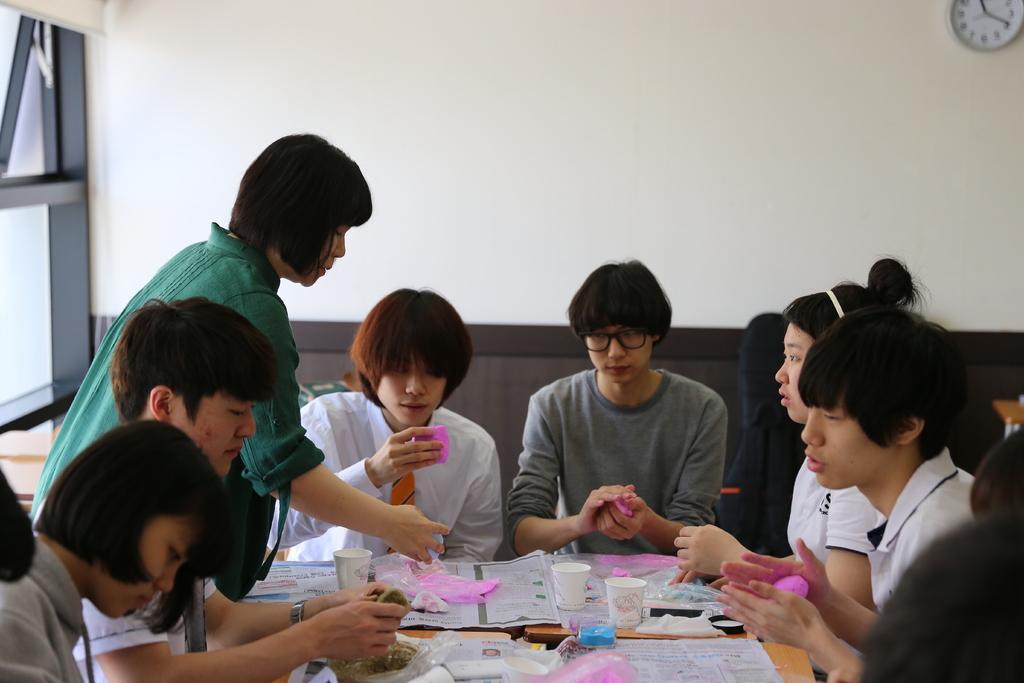Describe this image in one or two sentences. Here we can see few persons are sitting on the chairs around a table. On the table we can see papers, cups, and bottles. In the background we can see wall and a clock. 